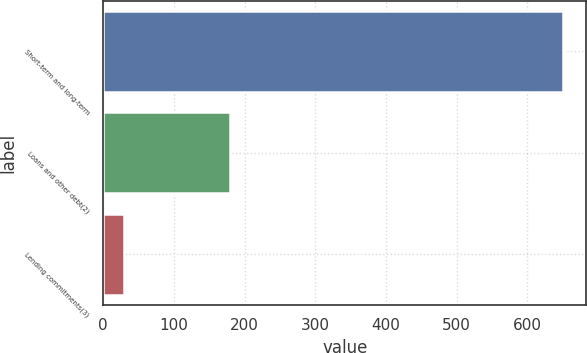<chart> <loc_0><loc_0><loc_500><loc_500><bar_chart><fcel>Short-term and long-term<fcel>Loans and other debt(2)<fcel>Lending commitments(3)<nl><fcel>651<fcel>179<fcel>30<nl></chart> 